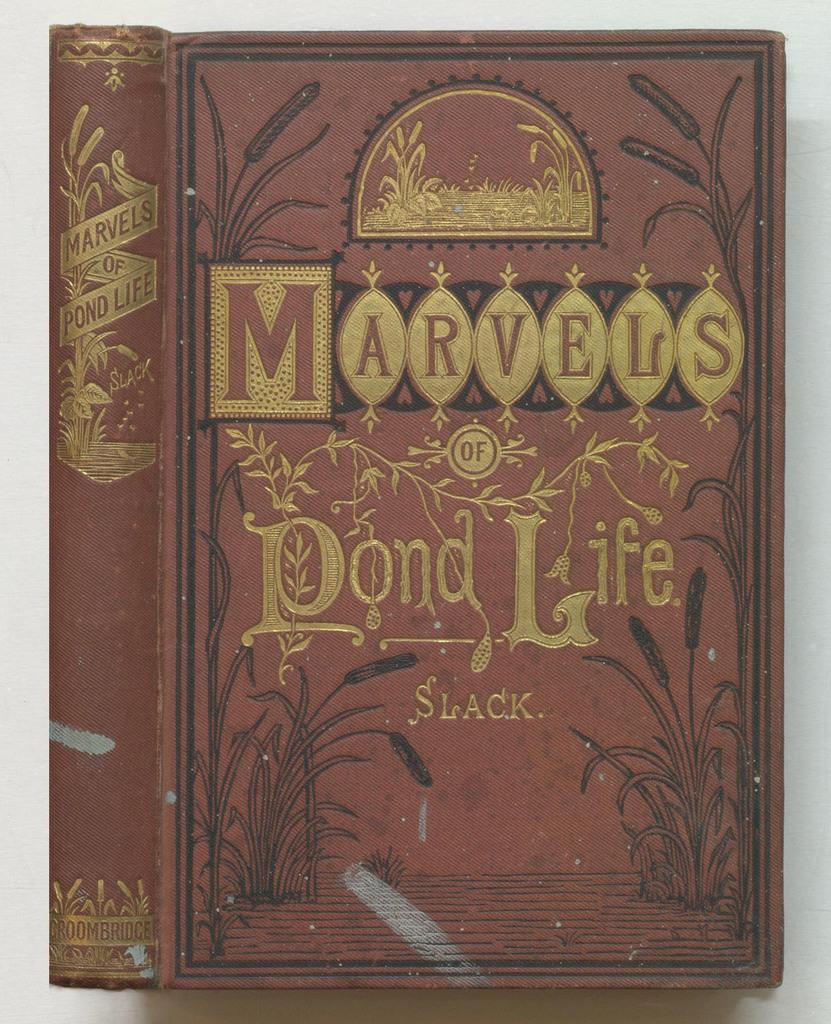What is the name of this book?
Make the answer very short. Marvels of pond life. What word is written at the bottom of the cover?
Your response must be concise. Slack. 